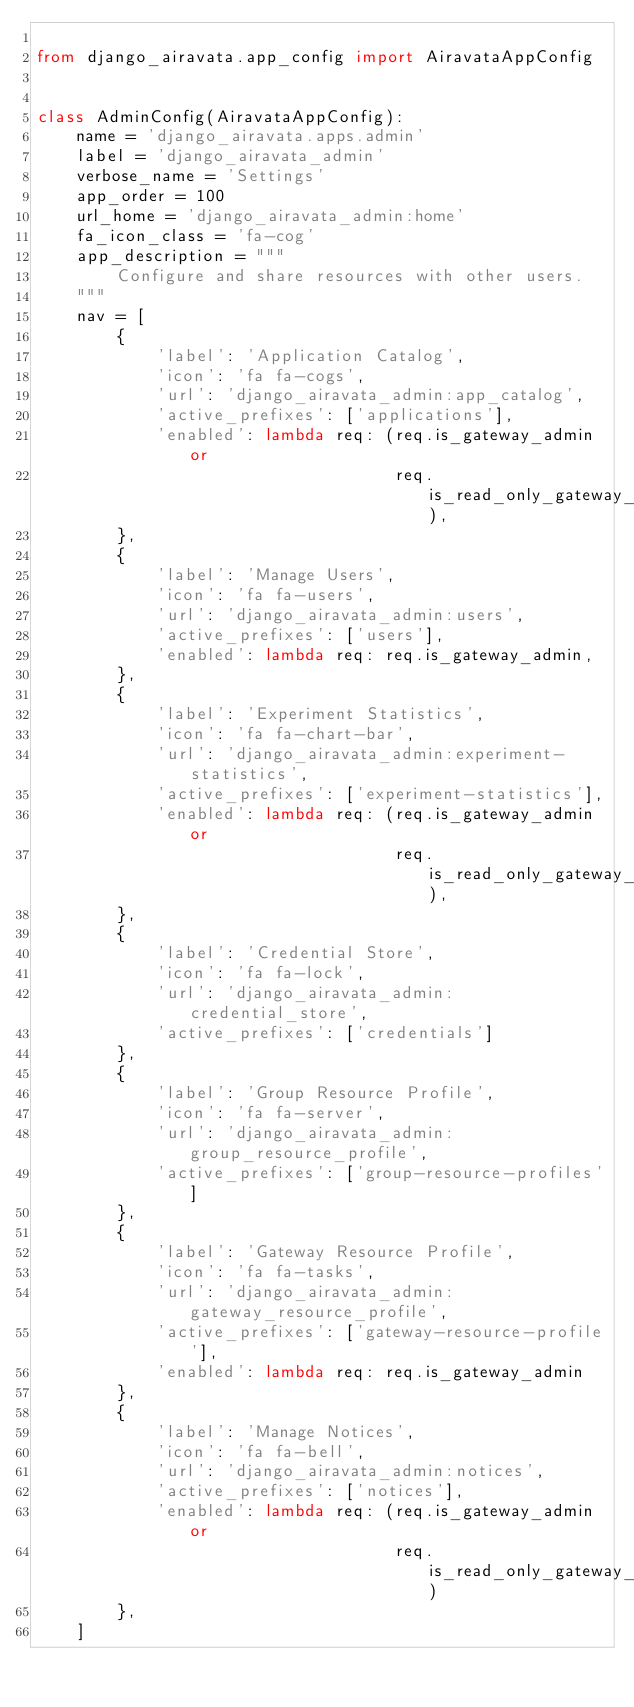Convert code to text. <code><loc_0><loc_0><loc_500><loc_500><_Python_>
from django_airavata.app_config import AiravataAppConfig


class AdminConfig(AiravataAppConfig):
    name = 'django_airavata.apps.admin'
    label = 'django_airavata_admin'
    verbose_name = 'Settings'
    app_order = 100
    url_home = 'django_airavata_admin:home'
    fa_icon_class = 'fa-cog'
    app_description = """
        Configure and share resources with other users.
    """
    nav = [
        {
            'label': 'Application Catalog',
            'icon': 'fa fa-cogs',
            'url': 'django_airavata_admin:app_catalog',
            'active_prefixes': ['applications'],
            'enabled': lambda req: (req.is_gateway_admin or
                                    req.is_read_only_gateway_admin),
        },
        {
            'label': 'Manage Users',
            'icon': 'fa fa-users',
            'url': 'django_airavata_admin:users',
            'active_prefixes': ['users'],
            'enabled': lambda req: req.is_gateway_admin,
        },
        {
            'label': 'Experiment Statistics',
            'icon': 'fa fa-chart-bar',
            'url': 'django_airavata_admin:experiment-statistics',
            'active_prefixes': ['experiment-statistics'],
            'enabled': lambda req: (req.is_gateway_admin or
                                    req.is_read_only_gateway_admin),
        },
        {
            'label': 'Credential Store',
            'icon': 'fa fa-lock',
            'url': 'django_airavata_admin:credential_store',
            'active_prefixes': ['credentials']
        },
        {
            'label': 'Group Resource Profile',
            'icon': 'fa fa-server',
            'url': 'django_airavata_admin:group_resource_profile',
            'active_prefixes': ['group-resource-profiles']
        },
        {
            'label': 'Gateway Resource Profile',
            'icon': 'fa fa-tasks',
            'url': 'django_airavata_admin:gateway_resource_profile',
            'active_prefixes': ['gateway-resource-profile'],
            'enabled': lambda req: req.is_gateway_admin
        },
        {
            'label': 'Manage Notices',
            'icon': 'fa fa-bell',
            'url': 'django_airavata_admin:notices',
            'active_prefixes': ['notices'],
            'enabled': lambda req: (req.is_gateway_admin or
                                    req.is_read_only_gateway_admin)
        },
    ]
</code> 